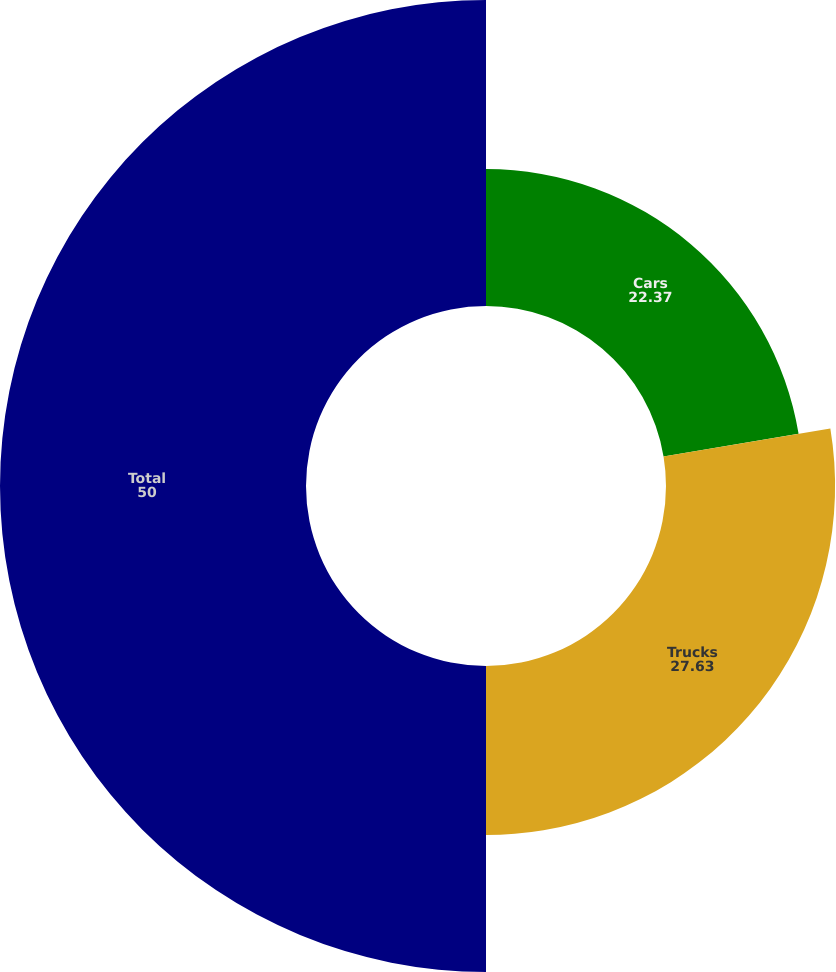<chart> <loc_0><loc_0><loc_500><loc_500><pie_chart><fcel>Cars<fcel>Trucks<fcel>Total<nl><fcel>22.37%<fcel>27.63%<fcel>50.0%<nl></chart> 